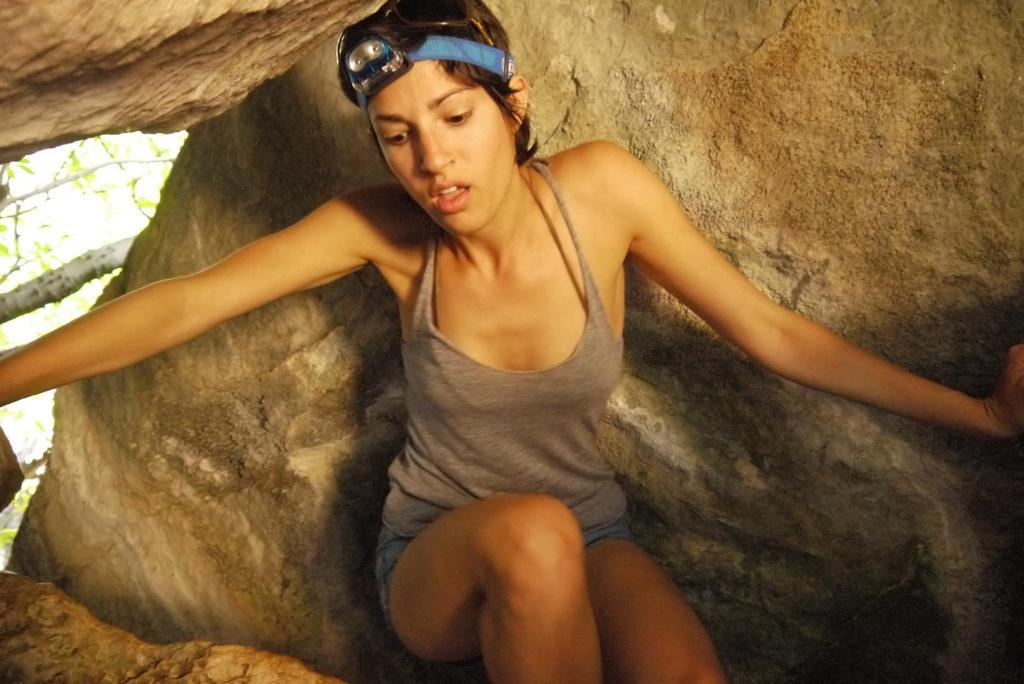Where was the image taken? The image is taken outdoors. What can be seen in the background of the image? There is a rock and a tree in the background of the image. Who is the main subject in the image? There is a woman in the middle of the image. What type of scissors can be seen in the woman's hand in the image? There are no scissors present in the image; the woman's hands are not visible. 